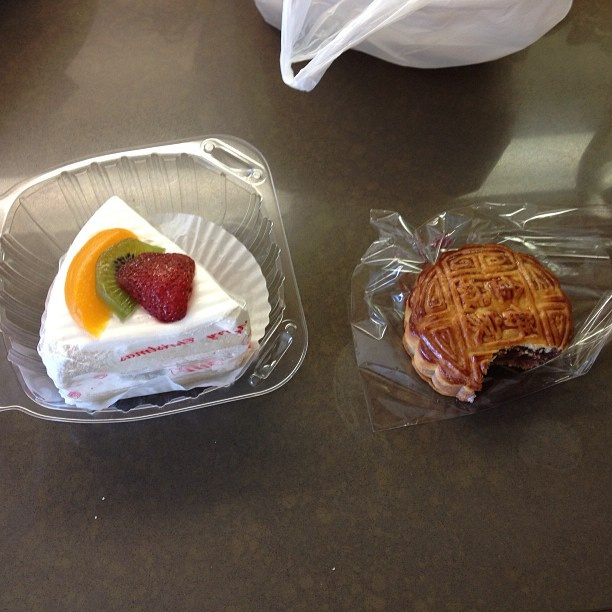Describe the objects in this image and their specific colors. I can see dining table in black, gray, and darkgray tones, bowl in black, darkgray, white, gray, and tan tones, cake in black, white, darkgray, maroon, and orange tones, and cake in black, brown, and maroon tones in this image. 